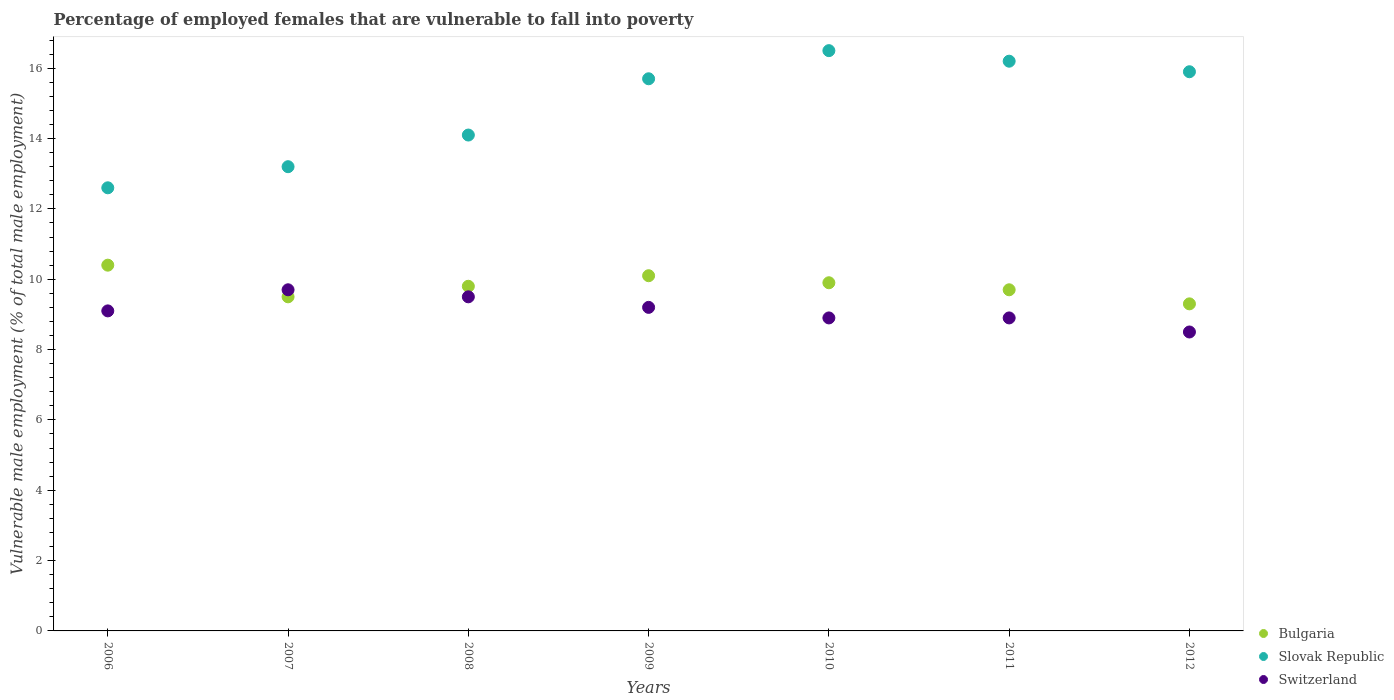How many different coloured dotlines are there?
Ensure brevity in your answer.  3. Is the number of dotlines equal to the number of legend labels?
Your answer should be compact. Yes. Across all years, what is the maximum percentage of employed females who are vulnerable to fall into poverty in Bulgaria?
Keep it short and to the point. 10.4. Across all years, what is the minimum percentage of employed females who are vulnerable to fall into poverty in Bulgaria?
Give a very brief answer. 9.3. In which year was the percentage of employed females who are vulnerable to fall into poverty in Bulgaria maximum?
Give a very brief answer. 2006. In which year was the percentage of employed females who are vulnerable to fall into poverty in Slovak Republic minimum?
Keep it short and to the point. 2006. What is the total percentage of employed females who are vulnerable to fall into poverty in Switzerland in the graph?
Keep it short and to the point. 63.8. What is the difference between the percentage of employed females who are vulnerable to fall into poverty in Slovak Republic in 2006 and that in 2007?
Give a very brief answer. -0.6. What is the difference between the percentage of employed females who are vulnerable to fall into poverty in Slovak Republic in 2011 and the percentage of employed females who are vulnerable to fall into poverty in Switzerland in 2008?
Ensure brevity in your answer.  6.7. What is the average percentage of employed females who are vulnerable to fall into poverty in Switzerland per year?
Provide a succinct answer. 9.11. In the year 2012, what is the difference between the percentage of employed females who are vulnerable to fall into poverty in Bulgaria and percentage of employed females who are vulnerable to fall into poverty in Switzerland?
Keep it short and to the point. 0.8. What is the ratio of the percentage of employed females who are vulnerable to fall into poverty in Slovak Republic in 2006 to that in 2010?
Offer a very short reply. 0.76. What is the difference between the highest and the second highest percentage of employed females who are vulnerable to fall into poverty in Switzerland?
Your response must be concise. 0.2. What is the difference between the highest and the lowest percentage of employed females who are vulnerable to fall into poverty in Switzerland?
Keep it short and to the point. 1.2. In how many years, is the percentage of employed females who are vulnerable to fall into poverty in Slovak Republic greater than the average percentage of employed females who are vulnerable to fall into poverty in Slovak Republic taken over all years?
Make the answer very short. 4. Is the sum of the percentage of employed females who are vulnerable to fall into poverty in Switzerland in 2008 and 2009 greater than the maximum percentage of employed females who are vulnerable to fall into poverty in Slovak Republic across all years?
Offer a very short reply. Yes. Is it the case that in every year, the sum of the percentage of employed females who are vulnerable to fall into poverty in Bulgaria and percentage of employed females who are vulnerable to fall into poverty in Switzerland  is greater than the percentage of employed females who are vulnerable to fall into poverty in Slovak Republic?
Provide a short and direct response. Yes. What is the difference between two consecutive major ticks on the Y-axis?
Ensure brevity in your answer.  2. Does the graph contain any zero values?
Give a very brief answer. No. Where does the legend appear in the graph?
Your answer should be compact. Bottom right. What is the title of the graph?
Offer a very short reply. Percentage of employed females that are vulnerable to fall into poverty. What is the label or title of the X-axis?
Offer a terse response. Years. What is the label or title of the Y-axis?
Give a very brief answer. Vulnerable male employment (% of total male employment). What is the Vulnerable male employment (% of total male employment) of Bulgaria in 2006?
Provide a short and direct response. 10.4. What is the Vulnerable male employment (% of total male employment) in Slovak Republic in 2006?
Your response must be concise. 12.6. What is the Vulnerable male employment (% of total male employment) in Switzerland in 2006?
Offer a very short reply. 9.1. What is the Vulnerable male employment (% of total male employment) in Bulgaria in 2007?
Your answer should be compact. 9.5. What is the Vulnerable male employment (% of total male employment) of Slovak Republic in 2007?
Provide a succinct answer. 13.2. What is the Vulnerable male employment (% of total male employment) in Switzerland in 2007?
Provide a succinct answer. 9.7. What is the Vulnerable male employment (% of total male employment) of Bulgaria in 2008?
Offer a terse response. 9.8. What is the Vulnerable male employment (% of total male employment) in Slovak Republic in 2008?
Your response must be concise. 14.1. What is the Vulnerable male employment (% of total male employment) of Bulgaria in 2009?
Make the answer very short. 10.1. What is the Vulnerable male employment (% of total male employment) in Slovak Republic in 2009?
Offer a terse response. 15.7. What is the Vulnerable male employment (% of total male employment) in Switzerland in 2009?
Keep it short and to the point. 9.2. What is the Vulnerable male employment (% of total male employment) in Bulgaria in 2010?
Offer a terse response. 9.9. What is the Vulnerable male employment (% of total male employment) in Slovak Republic in 2010?
Provide a short and direct response. 16.5. What is the Vulnerable male employment (% of total male employment) in Switzerland in 2010?
Keep it short and to the point. 8.9. What is the Vulnerable male employment (% of total male employment) of Bulgaria in 2011?
Your answer should be compact. 9.7. What is the Vulnerable male employment (% of total male employment) in Slovak Republic in 2011?
Keep it short and to the point. 16.2. What is the Vulnerable male employment (% of total male employment) of Switzerland in 2011?
Provide a succinct answer. 8.9. What is the Vulnerable male employment (% of total male employment) in Bulgaria in 2012?
Offer a terse response. 9.3. What is the Vulnerable male employment (% of total male employment) in Slovak Republic in 2012?
Provide a short and direct response. 15.9. Across all years, what is the maximum Vulnerable male employment (% of total male employment) of Bulgaria?
Your response must be concise. 10.4. Across all years, what is the maximum Vulnerable male employment (% of total male employment) in Switzerland?
Keep it short and to the point. 9.7. Across all years, what is the minimum Vulnerable male employment (% of total male employment) in Bulgaria?
Your answer should be very brief. 9.3. Across all years, what is the minimum Vulnerable male employment (% of total male employment) of Slovak Republic?
Your answer should be compact. 12.6. Across all years, what is the minimum Vulnerable male employment (% of total male employment) in Switzerland?
Offer a terse response. 8.5. What is the total Vulnerable male employment (% of total male employment) of Bulgaria in the graph?
Provide a short and direct response. 68.7. What is the total Vulnerable male employment (% of total male employment) of Slovak Republic in the graph?
Provide a succinct answer. 104.2. What is the total Vulnerable male employment (% of total male employment) of Switzerland in the graph?
Provide a succinct answer. 63.8. What is the difference between the Vulnerable male employment (% of total male employment) in Slovak Republic in 2006 and that in 2007?
Keep it short and to the point. -0.6. What is the difference between the Vulnerable male employment (% of total male employment) in Switzerland in 2006 and that in 2007?
Keep it short and to the point. -0.6. What is the difference between the Vulnerable male employment (% of total male employment) of Bulgaria in 2006 and that in 2008?
Ensure brevity in your answer.  0.6. What is the difference between the Vulnerable male employment (% of total male employment) of Slovak Republic in 2006 and that in 2008?
Keep it short and to the point. -1.5. What is the difference between the Vulnerable male employment (% of total male employment) of Switzerland in 2006 and that in 2008?
Offer a very short reply. -0.4. What is the difference between the Vulnerable male employment (% of total male employment) of Bulgaria in 2006 and that in 2009?
Offer a terse response. 0.3. What is the difference between the Vulnerable male employment (% of total male employment) of Slovak Republic in 2006 and that in 2009?
Your answer should be very brief. -3.1. What is the difference between the Vulnerable male employment (% of total male employment) in Switzerland in 2006 and that in 2009?
Make the answer very short. -0.1. What is the difference between the Vulnerable male employment (% of total male employment) in Bulgaria in 2006 and that in 2011?
Give a very brief answer. 0.7. What is the difference between the Vulnerable male employment (% of total male employment) in Switzerland in 2006 and that in 2011?
Your answer should be very brief. 0.2. What is the difference between the Vulnerable male employment (% of total male employment) in Bulgaria in 2006 and that in 2012?
Offer a very short reply. 1.1. What is the difference between the Vulnerable male employment (% of total male employment) of Slovak Republic in 2006 and that in 2012?
Provide a short and direct response. -3.3. What is the difference between the Vulnerable male employment (% of total male employment) in Switzerland in 2006 and that in 2012?
Keep it short and to the point. 0.6. What is the difference between the Vulnerable male employment (% of total male employment) in Slovak Republic in 2007 and that in 2008?
Give a very brief answer. -0.9. What is the difference between the Vulnerable male employment (% of total male employment) in Bulgaria in 2007 and that in 2009?
Your answer should be very brief. -0.6. What is the difference between the Vulnerable male employment (% of total male employment) of Bulgaria in 2007 and that in 2010?
Give a very brief answer. -0.4. What is the difference between the Vulnerable male employment (% of total male employment) in Slovak Republic in 2007 and that in 2011?
Provide a succinct answer. -3. What is the difference between the Vulnerable male employment (% of total male employment) in Bulgaria in 2007 and that in 2012?
Your response must be concise. 0.2. What is the difference between the Vulnerable male employment (% of total male employment) in Slovak Republic in 2008 and that in 2009?
Give a very brief answer. -1.6. What is the difference between the Vulnerable male employment (% of total male employment) of Bulgaria in 2008 and that in 2010?
Give a very brief answer. -0.1. What is the difference between the Vulnerable male employment (% of total male employment) of Slovak Republic in 2008 and that in 2010?
Provide a succinct answer. -2.4. What is the difference between the Vulnerable male employment (% of total male employment) of Bulgaria in 2008 and that in 2011?
Ensure brevity in your answer.  0.1. What is the difference between the Vulnerable male employment (% of total male employment) in Slovak Republic in 2008 and that in 2011?
Offer a very short reply. -2.1. What is the difference between the Vulnerable male employment (% of total male employment) in Switzerland in 2008 and that in 2012?
Offer a terse response. 1. What is the difference between the Vulnerable male employment (% of total male employment) of Bulgaria in 2009 and that in 2012?
Provide a succinct answer. 0.8. What is the difference between the Vulnerable male employment (% of total male employment) of Slovak Republic in 2009 and that in 2012?
Make the answer very short. -0.2. What is the difference between the Vulnerable male employment (% of total male employment) in Slovak Republic in 2010 and that in 2011?
Provide a short and direct response. 0.3. What is the difference between the Vulnerable male employment (% of total male employment) in Switzerland in 2010 and that in 2011?
Keep it short and to the point. 0. What is the difference between the Vulnerable male employment (% of total male employment) in Slovak Republic in 2010 and that in 2012?
Make the answer very short. 0.6. What is the difference between the Vulnerable male employment (% of total male employment) in Bulgaria in 2006 and the Vulnerable male employment (% of total male employment) in Slovak Republic in 2007?
Your answer should be compact. -2.8. What is the difference between the Vulnerable male employment (% of total male employment) in Slovak Republic in 2006 and the Vulnerable male employment (% of total male employment) in Switzerland in 2007?
Your answer should be compact. 2.9. What is the difference between the Vulnerable male employment (% of total male employment) of Bulgaria in 2006 and the Vulnerable male employment (% of total male employment) of Slovak Republic in 2008?
Your answer should be very brief. -3.7. What is the difference between the Vulnerable male employment (% of total male employment) in Bulgaria in 2006 and the Vulnerable male employment (% of total male employment) in Switzerland in 2008?
Make the answer very short. 0.9. What is the difference between the Vulnerable male employment (% of total male employment) of Bulgaria in 2006 and the Vulnerable male employment (% of total male employment) of Switzerland in 2009?
Your answer should be compact. 1.2. What is the difference between the Vulnerable male employment (% of total male employment) of Slovak Republic in 2006 and the Vulnerable male employment (% of total male employment) of Switzerland in 2010?
Your answer should be compact. 3.7. What is the difference between the Vulnerable male employment (% of total male employment) of Bulgaria in 2006 and the Vulnerable male employment (% of total male employment) of Switzerland in 2011?
Offer a terse response. 1.5. What is the difference between the Vulnerable male employment (% of total male employment) of Slovak Republic in 2006 and the Vulnerable male employment (% of total male employment) of Switzerland in 2011?
Provide a succinct answer. 3.7. What is the difference between the Vulnerable male employment (% of total male employment) of Bulgaria in 2006 and the Vulnerable male employment (% of total male employment) of Switzerland in 2012?
Offer a very short reply. 1.9. What is the difference between the Vulnerable male employment (% of total male employment) of Slovak Republic in 2006 and the Vulnerable male employment (% of total male employment) of Switzerland in 2012?
Keep it short and to the point. 4.1. What is the difference between the Vulnerable male employment (% of total male employment) in Bulgaria in 2007 and the Vulnerable male employment (% of total male employment) in Slovak Republic in 2008?
Your answer should be compact. -4.6. What is the difference between the Vulnerable male employment (% of total male employment) in Slovak Republic in 2007 and the Vulnerable male employment (% of total male employment) in Switzerland in 2010?
Provide a succinct answer. 4.3. What is the difference between the Vulnerable male employment (% of total male employment) of Bulgaria in 2007 and the Vulnerable male employment (% of total male employment) of Slovak Republic in 2011?
Make the answer very short. -6.7. What is the difference between the Vulnerable male employment (% of total male employment) in Bulgaria in 2007 and the Vulnerable male employment (% of total male employment) in Switzerland in 2011?
Ensure brevity in your answer.  0.6. What is the difference between the Vulnerable male employment (% of total male employment) of Slovak Republic in 2007 and the Vulnerable male employment (% of total male employment) of Switzerland in 2011?
Your answer should be very brief. 4.3. What is the difference between the Vulnerable male employment (% of total male employment) in Bulgaria in 2007 and the Vulnerable male employment (% of total male employment) in Switzerland in 2012?
Your response must be concise. 1. What is the difference between the Vulnerable male employment (% of total male employment) of Bulgaria in 2008 and the Vulnerable male employment (% of total male employment) of Slovak Republic in 2009?
Your response must be concise. -5.9. What is the difference between the Vulnerable male employment (% of total male employment) of Bulgaria in 2008 and the Vulnerable male employment (% of total male employment) of Slovak Republic in 2010?
Keep it short and to the point. -6.7. What is the difference between the Vulnerable male employment (% of total male employment) of Bulgaria in 2008 and the Vulnerable male employment (% of total male employment) of Slovak Republic in 2011?
Provide a succinct answer. -6.4. What is the difference between the Vulnerable male employment (% of total male employment) in Slovak Republic in 2008 and the Vulnerable male employment (% of total male employment) in Switzerland in 2011?
Offer a terse response. 5.2. What is the difference between the Vulnerable male employment (% of total male employment) in Bulgaria in 2008 and the Vulnerable male employment (% of total male employment) in Slovak Republic in 2012?
Give a very brief answer. -6.1. What is the difference between the Vulnerable male employment (% of total male employment) of Slovak Republic in 2008 and the Vulnerable male employment (% of total male employment) of Switzerland in 2012?
Ensure brevity in your answer.  5.6. What is the difference between the Vulnerable male employment (% of total male employment) of Bulgaria in 2009 and the Vulnerable male employment (% of total male employment) of Slovak Republic in 2011?
Provide a succinct answer. -6.1. What is the difference between the Vulnerable male employment (% of total male employment) in Slovak Republic in 2009 and the Vulnerable male employment (% of total male employment) in Switzerland in 2011?
Provide a short and direct response. 6.8. What is the difference between the Vulnerable male employment (% of total male employment) in Bulgaria in 2009 and the Vulnerable male employment (% of total male employment) in Slovak Republic in 2012?
Give a very brief answer. -5.8. What is the difference between the Vulnerable male employment (% of total male employment) in Slovak Republic in 2009 and the Vulnerable male employment (% of total male employment) in Switzerland in 2012?
Make the answer very short. 7.2. What is the difference between the Vulnerable male employment (% of total male employment) in Bulgaria in 2010 and the Vulnerable male employment (% of total male employment) in Slovak Republic in 2011?
Your answer should be very brief. -6.3. What is the difference between the Vulnerable male employment (% of total male employment) of Bulgaria in 2010 and the Vulnerable male employment (% of total male employment) of Switzerland in 2011?
Offer a terse response. 1. What is the difference between the Vulnerable male employment (% of total male employment) in Slovak Republic in 2010 and the Vulnerable male employment (% of total male employment) in Switzerland in 2011?
Ensure brevity in your answer.  7.6. What is the difference between the Vulnerable male employment (% of total male employment) of Bulgaria in 2011 and the Vulnerable male employment (% of total male employment) of Slovak Republic in 2012?
Keep it short and to the point. -6.2. What is the difference between the Vulnerable male employment (% of total male employment) in Bulgaria in 2011 and the Vulnerable male employment (% of total male employment) in Switzerland in 2012?
Provide a short and direct response. 1.2. What is the average Vulnerable male employment (% of total male employment) in Bulgaria per year?
Your answer should be compact. 9.81. What is the average Vulnerable male employment (% of total male employment) in Slovak Republic per year?
Provide a succinct answer. 14.89. What is the average Vulnerable male employment (% of total male employment) in Switzerland per year?
Your answer should be compact. 9.11. In the year 2006, what is the difference between the Vulnerable male employment (% of total male employment) in Bulgaria and Vulnerable male employment (% of total male employment) in Slovak Republic?
Make the answer very short. -2.2. In the year 2006, what is the difference between the Vulnerable male employment (% of total male employment) of Bulgaria and Vulnerable male employment (% of total male employment) of Switzerland?
Ensure brevity in your answer.  1.3. In the year 2007, what is the difference between the Vulnerable male employment (% of total male employment) in Bulgaria and Vulnerable male employment (% of total male employment) in Slovak Republic?
Keep it short and to the point. -3.7. In the year 2007, what is the difference between the Vulnerable male employment (% of total male employment) of Slovak Republic and Vulnerable male employment (% of total male employment) of Switzerland?
Offer a very short reply. 3.5. In the year 2008, what is the difference between the Vulnerable male employment (% of total male employment) of Bulgaria and Vulnerable male employment (% of total male employment) of Slovak Republic?
Your response must be concise. -4.3. In the year 2009, what is the difference between the Vulnerable male employment (% of total male employment) of Bulgaria and Vulnerable male employment (% of total male employment) of Switzerland?
Provide a short and direct response. 0.9. In the year 2010, what is the difference between the Vulnerable male employment (% of total male employment) in Bulgaria and Vulnerable male employment (% of total male employment) in Slovak Republic?
Your answer should be compact. -6.6. In the year 2011, what is the difference between the Vulnerable male employment (% of total male employment) in Bulgaria and Vulnerable male employment (% of total male employment) in Slovak Republic?
Keep it short and to the point. -6.5. In the year 2011, what is the difference between the Vulnerable male employment (% of total male employment) in Slovak Republic and Vulnerable male employment (% of total male employment) in Switzerland?
Your answer should be compact. 7.3. In the year 2012, what is the difference between the Vulnerable male employment (% of total male employment) of Bulgaria and Vulnerable male employment (% of total male employment) of Slovak Republic?
Provide a short and direct response. -6.6. In the year 2012, what is the difference between the Vulnerable male employment (% of total male employment) of Slovak Republic and Vulnerable male employment (% of total male employment) of Switzerland?
Your answer should be compact. 7.4. What is the ratio of the Vulnerable male employment (% of total male employment) of Bulgaria in 2006 to that in 2007?
Provide a succinct answer. 1.09. What is the ratio of the Vulnerable male employment (% of total male employment) in Slovak Republic in 2006 to that in 2007?
Offer a terse response. 0.95. What is the ratio of the Vulnerable male employment (% of total male employment) in Switzerland in 2006 to that in 2007?
Your answer should be compact. 0.94. What is the ratio of the Vulnerable male employment (% of total male employment) in Bulgaria in 2006 to that in 2008?
Offer a very short reply. 1.06. What is the ratio of the Vulnerable male employment (% of total male employment) of Slovak Republic in 2006 to that in 2008?
Your answer should be very brief. 0.89. What is the ratio of the Vulnerable male employment (% of total male employment) in Switzerland in 2006 to that in 2008?
Your answer should be very brief. 0.96. What is the ratio of the Vulnerable male employment (% of total male employment) of Bulgaria in 2006 to that in 2009?
Your answer should be compact. 1.03. What is the ratio of the Vulnerable male employment (% of total male employment) in Slovak Republic in 2006 to that in 2009?
Keep it short and to the point. 0.8. What is the ratio of the Vulnerable male employment (% of total male employment) in Bulgaria in 2006 to that in 2010?
Your answer should be very brief. 1.05. What is the ratio of the Vulnerable male employment (% of total male employment) of Slovak Republic in 2006 to that in 2010?
Your answer should be compact. 0.76. What is the ratio of the Vulnerable male employment (% of total male employment) of Switzerland in 2006 to that in 2010?
Your response must be concise. 1.02. What is the ratio of the Vulnerable male employment (% of total male employment) of Bulgaria in 2006 to that in 2011?
Provide a succinct answer. 1.07. What is the ratio of the Vulnerable male employment (% of total male employment) in Switzerland in 2006 to that in 2011?
Your answer should be compact. 1.02. What is the ratio of the Vulnerable male employment (% of total male employment) in Bulgaria in 2006 to that in 2012?
Make the answer very short. 1.12. What is the ratio of the Vulnerable male employment (% of total male employment) of Slovak Republic in 2006 to that in 2012?
Your answer should be compact. 0.79. What is the ratio of the Vulnerable male employment (% of total male employment) in Switzerland in 2006 to that in 2012?
Offer a terse response. 1.07. What is the ratio of the Vulnerable male employment (% of total male employment) of Bulgaria in 2007 to that in 2008?
Provide a succinct answer. 0.97. What is the ratio of the Vulnerable male employment (% of total male employment) of Slovak Republic in 2007 to that in 2008?
Offer a very short reply. 0.94. What is the ratio of the Vulnerable male employment (% of total male employment) in Switzerland in 2007 to that in 2008?
Keep it short and to the point. 1.02. What is the ratio of the Vulnerable male employment (% of total male employment) of Bulgaria in 2007 to that in 2009?
Your response must be concise. 0.94. What is the ratio of the Vulnerable male employment (% of total male employment) of Slovak Republic in 2007 to that in 2009?
Make the answer very short. 0.84. What is the ratio of the Vulnerable male employment (% of total male employment) of Switzerland in 2007 to that in 2009?
Your response must be concise. 1.05. What is the ratio of the Vulnerable male employment (% of total male employment) of Bulgaria in 2007 to that in 2010?
Your response must be concise. 0.96. What is the ratio of the Vulnerable male employment (% of total male employment) in Slovak Republic in 2007 to that in 2010?
Offer a very short reply. 0.8. What is the ratio of the Vulnerable male employment (% of total male employment) in Switzerland in 2007 to that in 2010?
Your answer should be compact. 1.09. What is the ratio of the Vulnerable male employment (% of total male employment) in Bulgaria in 2007 to that in 2011?
Your response must be concise. 0.98. What is the ratio of the Vulnerable male employment (% of total male employment) in Slovak Republic in 2007 to that in 2011?
Make the answer very short. 0.81. What is the ratio of the Vulnerable male employment (% of total male employment) of Switzerland in 2007 to that in 2011?
Provide a short and direct response. 1.09. What is the ratio of the Vulnerable male employment (% of total male employment) in Bulgaria in 2007 to that in 2012?
Your answer should be compact. 1.02. What is the ratio of the Vulnerable male employment (% of total male employment) of Slovak Republic in 2007 to that in 2012?
Your answer should be compact. 0.83. What is the ratio of the Vulnerable male employment (% of total male employment) of Switzerland in 2007 to that in 2012?
Keep it short and to the point. 1.14. What is the ratio of the Vulnerable male employment (% of total male employment) of Bulgaria in 2008 to that in 2009?
Offer a terse response. 0.97. What is the ratio of the Vulnerable male employment (% of total male employment) in Slovak Republic in 2008 to that in 2009?
Offer a terse response. 0.9. What is the ratio of the Vulnerable male employment (% of total male employment) of Switzerland in 2008 to that in 2009?
Your answer should be very brief. 1.03. What is the ratio of the Vulnerable male employment (% of total male employment) in Bulgaria in 2008 to that in 2010?
Your answer should be very brief. 0.99. What is the ratio of the Vulnerable male employment (% of total male employment) of Slovak Republic in 2008 to that in 2010?
Offer a very short reply. 0.85. What is the ratio of the Vulnerable male employment (% of total male employment) in Switzerland in 2008 to that in 2010?
Offer a very short reply. 1.07. What is the ratio of the Vulnerable male employment (% of total male employment) in Bulgaria in 2008 to that in 2011?
Give a very brief answer. 1.01. What is the ratio of the Vulnerable male employment (% of total male employment) in Slovak Republic in 2008 to that in 2011?
Offer a very short reply. 0.87. What is the ratio of the Vulnerable male employment (% of total male employment) of Switzerland in 2008 to that in 2011?
Offer a terse response. 1.07. What is the ratio of the Vulnerable male employment (% of total male employment) of Bulgaria in 2008 to that in 2012?
Make the answer very short. 1.05. What is the ratio of the Vulnerable male employment (% of total male employment) in Slovak Republic in 2008 to that in 2012?
Give a very brief answer. 0.89. What is the ratio of the Vulnerable male employment (% of total male employment) in Switzerland in 2008 to that in 2012?
Make the answer very short. 1.12. What is the ratio of the Vulnerable male employment (% of total male employment) in Bulgaria in 2009 to that in 2010?
Keep it short and to the point. 1.02. What is the ratio of the Vulnerable male employment (% of total male employment) in Slovak Republic in 2009 to that in 2010?
Make the answer very short. 0.95. What is the ratio of the Vulnerable male employment (% of total male employment) in Switzerland in 2009 to that in 2010?
Provide a succinct answer. 1.03. What is the ratio of the Vulnerable male employment (% of total male employment) in Bulgaria in 2009 to that in 2011?
Give a very brief answer. 1.04. What is the ratio of the Vulnerable male employment (% of total male employment) of Slovak Republic in 2009 to that in 2011?
Keep it short and to the point. 0.97. What is the ratio of the Vulnerable male employment (% of total male employment) in Switzerland in 2009 to that in 2011?
Make the answer very short. 1.03. What is the ratio of the Vulnerable male employment (% of total male employment) in Bulgaria in 2009 to that in 2012?
Provide a short and direct response. 1.09. What is the ratio of the Vulnerable male employment (% of total male employment) of Slovak Republic in 2009 to that in 2012?
Your answer should be very brief. 0.99. What is the ratio of the Vulnerable male employment (% of total male employment) in Switzerland in 2009 to that in 2012?
Offer a very short reply. 1.08. What is the ratio of the Vulnerable male employment (% of total male employment) of Bulgaria in 2010 to that in 2011?
Keep it short and to the point. 1.02. What is the ratio of the Vulnerable male employment (% of total male employment) in Slovak Republic in 2010 to that in 2011?
Offer a terse response. 1.02. What is the ratio of the Vulnerable male employment (% of total male employment) of Switzerland in 2010 to that in 2011?
Provide a succinct answer. 1. What is the ratio of the Vulnerable male employment (% of total male employment) in Bulgaria in 2010 to that in 2012?
Your answer should be compact. 1.06. What is the ratio of the Vulnerable male employment (% of total male employment) in Slovak Republic in 2010 to that in 2012?
Your response must be concise. 1.04. What is the ratio of the Vulnerable male employment (% of total male employment) in Switzerland in 2010 to that in 2012?
Give a very brief answer. 1.05. What is the ratio of the Vulnerable male employment (% of total male employment) of Bulgaria in 2011 to that in 2012?
Your answer should be very brief. 1.04. What is the ratio of the Vulnerable male employment (% of total male employment) in Slovak Republic in 2011 to that in 2012?
Your answer should be very brief. 1.02. What is the ratio of the Vulnerable male employment (% of total male employment) of Switzerland in 2011 to that in 2012?
Ensure brevity in your answer.  1.05. What is the difference between the highest and the lowest Vulnerable male employment (% of total male employment) of Bulgaria?
Your answer should be compact. 1.1. What is the difference between the highest and the lowest Vulnerable male employment (% of total male employment) in Slovak Republic?
Ensure brevity in your answer.  3.9. What is the difference between the highest and the lowest Vulnerable male employment (% of total male employment) in Switzerland?
Make the answer very short. 1.2. 